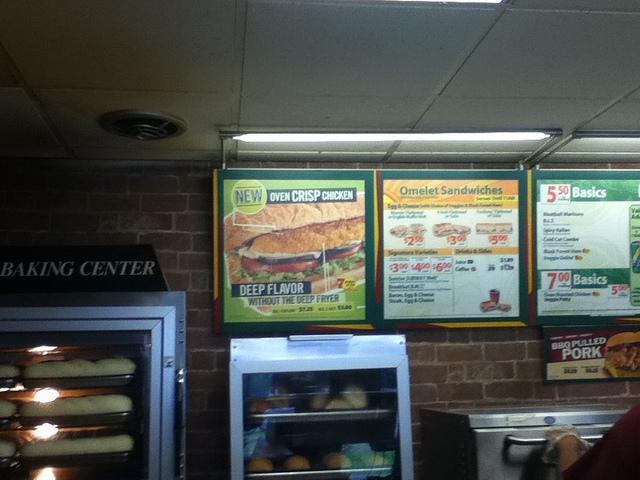How many ovens are there?
Give a very brief answer. 2. 